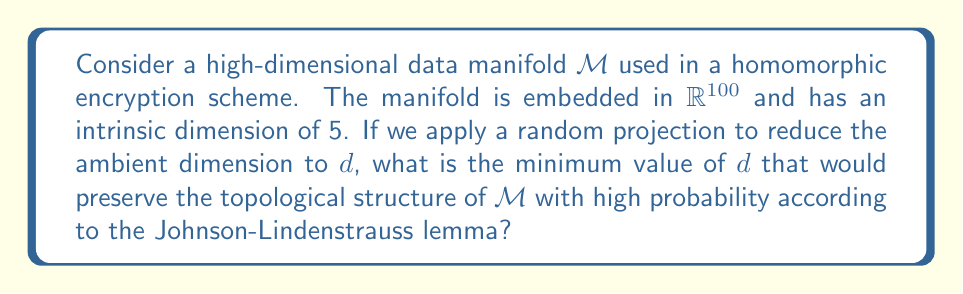Help me with this question. To solve this problem, we need to understand the Johnson-Lindenstrauss lemma and its implications for preserving the structure of high-dimensional data manifolds.

1) The Johnson-Lindenstrauss lemma states that a set of $n$ points in a high-dimensional space can be embedded into a lower-dimensional space while preserving pairwise distances up to a small distortion.

2) For a manifold $\mathcal{M}$ with intrinsic dimension $k$, we can consider it as a set of $n$ points where $n$ is exponential in $k$.

3) The lemma suggests that for $n$ points, we need a projection dimension $d$ that satisfies:

   $$d \geq \frac{C \log n}{\epsilon^2}$$

   where $C$ is a constant and $\epsilon$ is the allowed distortion.

4) In our case, $k = 5$ (intrinsic dimension), and we can estimate $n \approx 2^k = 2^5 = 32$.

5) For preserving topological structure, we typically want a small distortion, so let's use $\epsilon = 0.1$ and $C = 8$ (a common choice).

6) Plugging these values into the formula:

   $$d \geq \frac{8 \log 32}{0.1^2} = \frac{8 \cdot 5 \log 2}{0.01} = 4000 \log 2 \approx 2773$$

7) Since $d$ must be an integer, we round up to the nearest whole number.

This minimum dimension ensures that with high probability, the topological structure of the manifold is preserved after the random projection.
Answer: The minimum value of $d$ is 2773. 